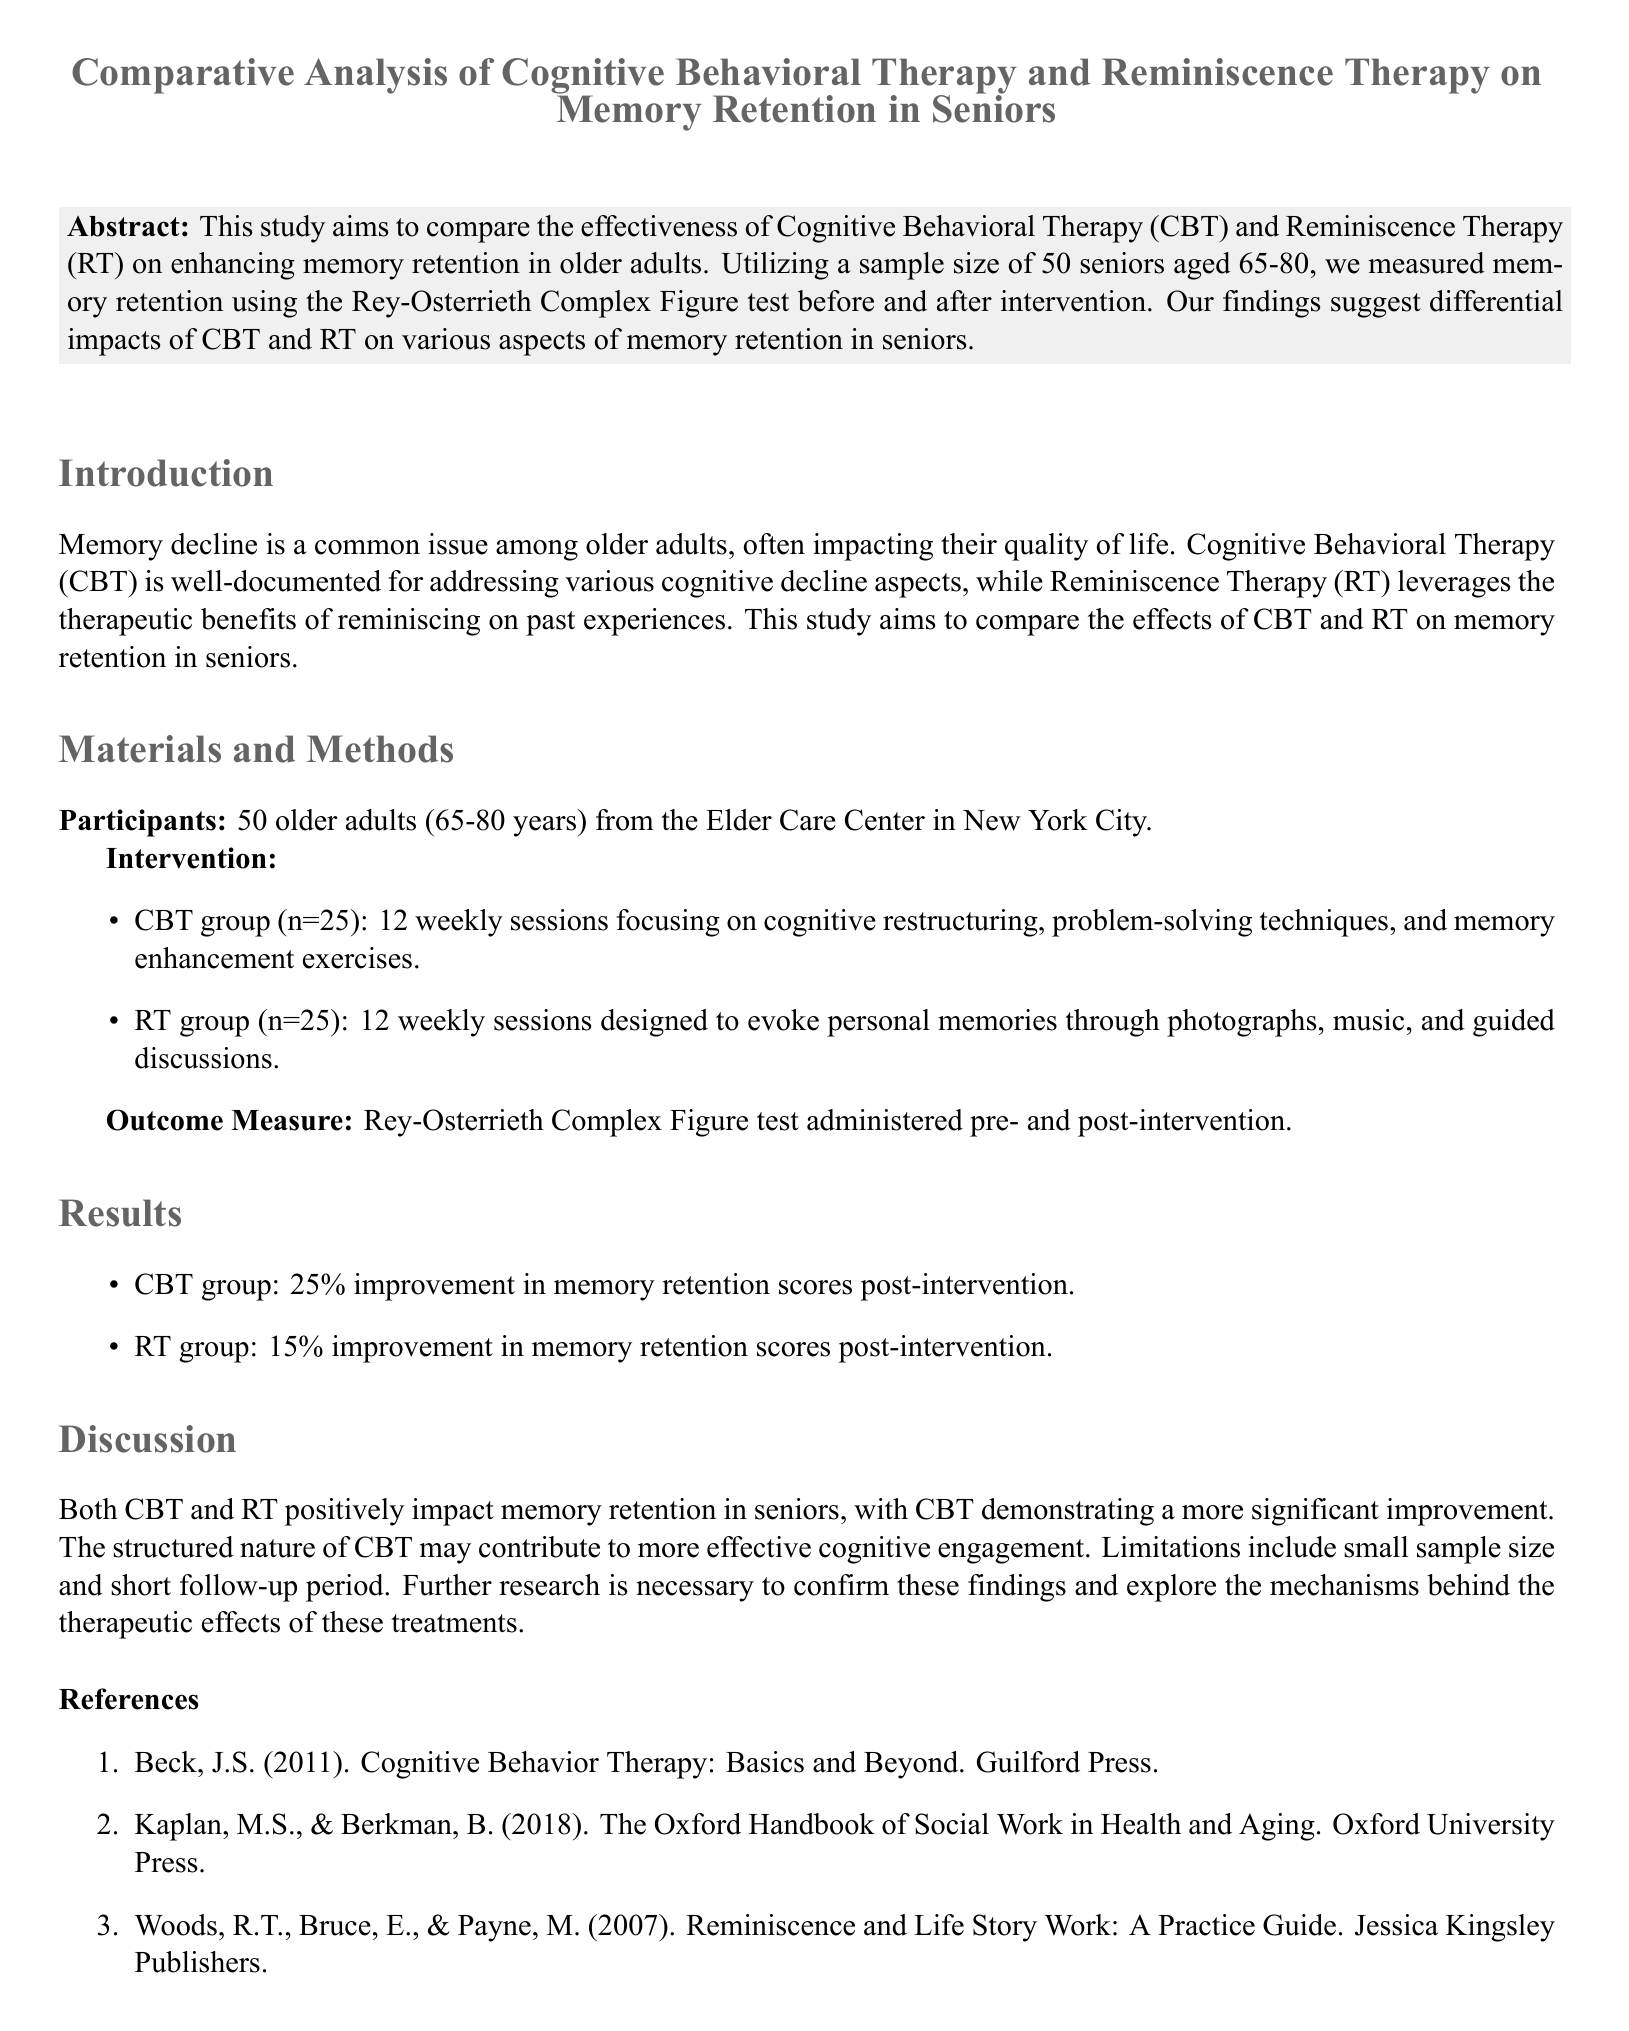What is the age range of the participants? The age range of the participants is specified in the document as 65 to 80 years.
Answer: 65-80 years How many sessions did the CBT group participate in? The document mentions that the CBT group participated in 12 weekly sessions.
Answer: 12 What was the improvement in memory retention scores for the CBT group? The results section specifies a 25% improvement in memory retention scores for the CBT group.
Answer: 25% What was the improvement in memory retention scores for the RT group? The findings indicate a 15% improvement in memory retention scores for the RT group.
Answer: 15% What is the name of the memory retention test used in the study? The memory retention test referred to in the study is the Rey-Osterrieth Complex Figure test.
Answer: Rey-Osterrieth Complex Figure test Which therapy showed a more significant improvement in memory retention? The discussion notes that Cognitive Behavioral Therapy (CBT) demonstrated a more significant improvement.
Answer: Cognitive Behavioral Therapy (CBT) What does RT stand for in the context of the document? The abbreviation RT refers to Reminiscence Therapy in the study.
Answer: Reminiscence Therapy What is identified as a limitation of the study? The discussion section identifies a small sample size and short follow-up period as limitations of the study.
Answer: Small sample size and short follow-up period 